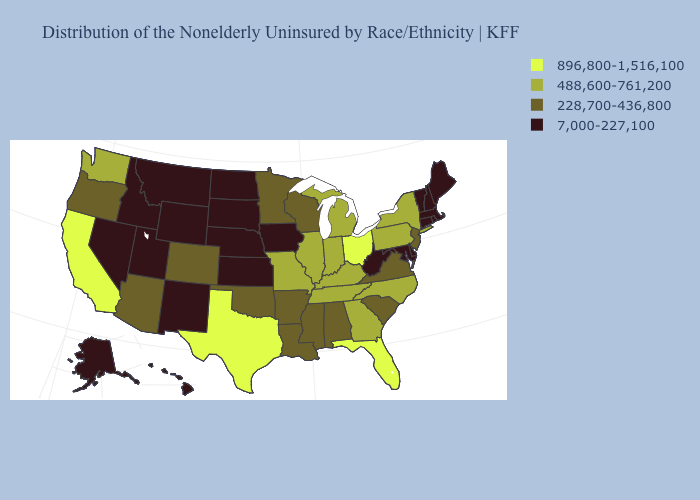Among the states that border Wisconsin , which have the highest value?
Write a very short answer. Illinois, Michigan. What is the value of Iowa?
Quick response, please. 7,000-227,100. What is the lowest value in the MidWest?
Keep it brief. 7,000-227,100. What is the value of Alaska?
Short answer required. 7,000-227,100. Among the states that border Arkansas , which have the highest value?
Be succinct. Texas. Name the states that have a value in the range 488,600-761,200?
Answer briefly. Georgia, Illinois, Indiana, Kentucky, Michigan, Missouri, New York, North Carolina, Pennsylvania, Tennessee, Washington. What is the value of Louisiana?
Give a very brief answer. 228,700-436,800. Does Tennessee have a higher value than Illinois?
Be succinct. No. Which states have the highest value in the USA?
Keep it brief. California, Florida, Ohio, Texas. What is the value of Nevada?
Answer briefly. 7,000-227,100. Among the states that border New Jersey , which have the lowest value?
Keep it brief. Delaware. What is the value of Kansas?
Be succinct. 7,000-227,100. Among the states that border Arkansas , which have the highest value?
Keep it brief. Texas. Does Maine have the lowest value in the Northeast?
Concise answer only. Yes. Does South Dakota have the lowest value in the MidWest?
Short answer required. Yes. 